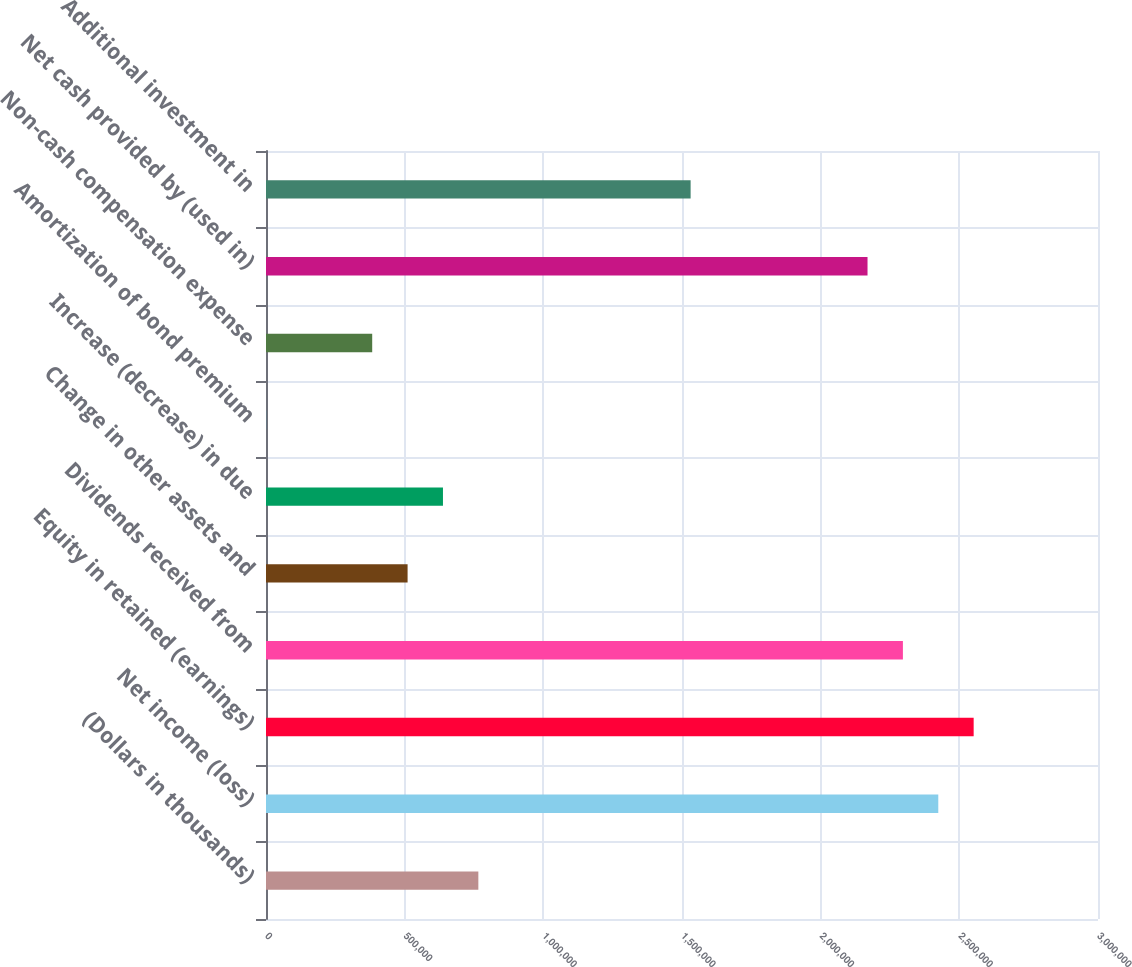Convert chart. <chart><loc_0><loc_0><loc_500><loc_500><bar_chart><fcel>(Dollars in thousands)<fcel>Net income (loss)<fcel>Equity in retained (earnings)<fcel>Dividends received from<fcel>Change in other assets and<fcel>Increase (decrease) in due<fcel>Amortization of bond premium<fcel>Non-cash compensation expense<fcel>Net cash provided by (used in)<fcel>Additional investment in<nl><fcel>765669<fcel>2.4241e+06<fcel>2.55167e+06<fcel>2.29653e+06<fcel>510527<fcel>638098<fcel>241<fcel>382955<fcel>2.16895e+06<fcel>1.5311e+06<nl></chart> 